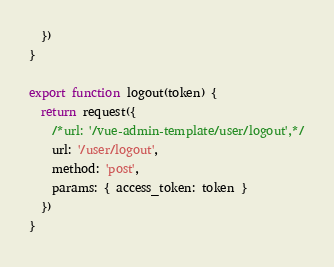<code> <loc_0><loc_0><loc_500><loc_500><_JavaScript_>  })
}

export function logout(token) {
  return request({
    /*url: '/vue-admin-template/user/logout',*/
    url: '/user/logout',
    method: 'post',
    params: { access_token: token }
  })
}
</code> 